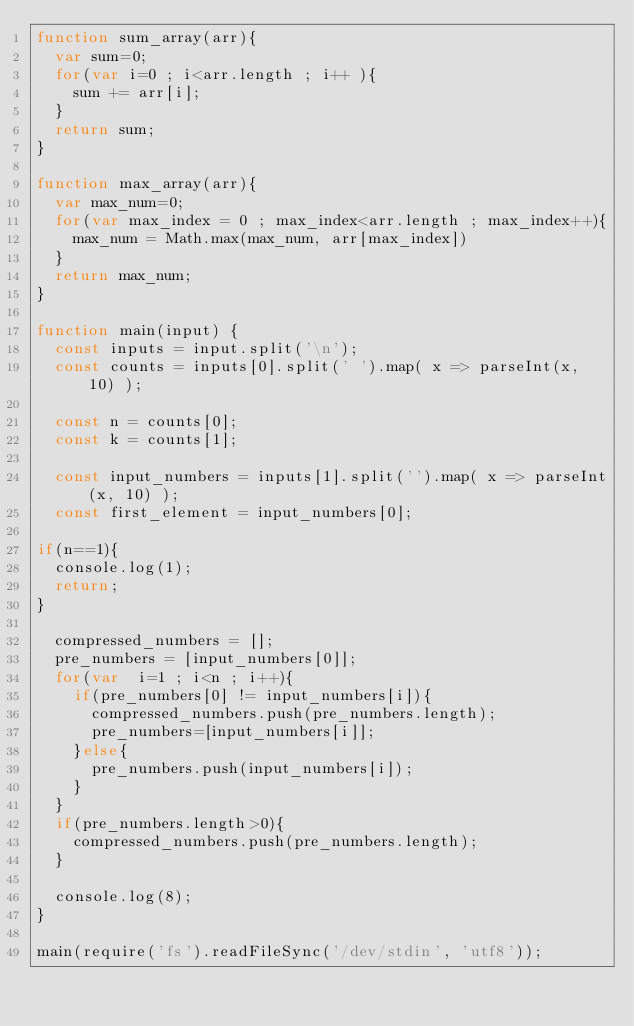Convert code to text. <code><loc_0><loc_0><loc_500><loc_500><_JavaScript_>function sum_array(arr){
  var sum=0;
  for(var i=0 ; i<arr.length ; i++ ){
    sum += arr[i];
  }
  return sum;
}

function max_array(arr){
  var max_num=0;
  for(var max_index = 0 ; max_index<arr.length ; max_index++){
    max_num = Math.max(max_num, arr[max_index])
  }
  return max_num;
}

function main(input) {
  const inputs = input.split('\n');
  const counts = inputs[0].split(' ').map( x => parseInt(x, 10) );

  const n = counts[0];
  const k = counts[1];

  const input_numbers = inputs[1].split('').map( x => parseInt(x, 10) );
  const first_element = input_numbers[0];

if(n==1){
  console.log(1);
  return;
}

  compressed_numbers = [];
  pre_numbers = [input_numbers[0]];
  for(var  i=1 ; i<n ; i++){
    if(pre_numbers[0] != input_numbers[i]){
      compressed_numbers.push(pre_numbers.length);
      pre_numbers=[input_numbers[i]];
    }else{
      pre_numbers.push(input_numbers[i]);
    }
  }
  if(pre_numbers.length>0){
    compressed_numbers.push(pre_numbers.length);
  }

  console.log(8);
}

main(require('fs').readFileSync('/dev/stdin', 'utf8'));
</code> 